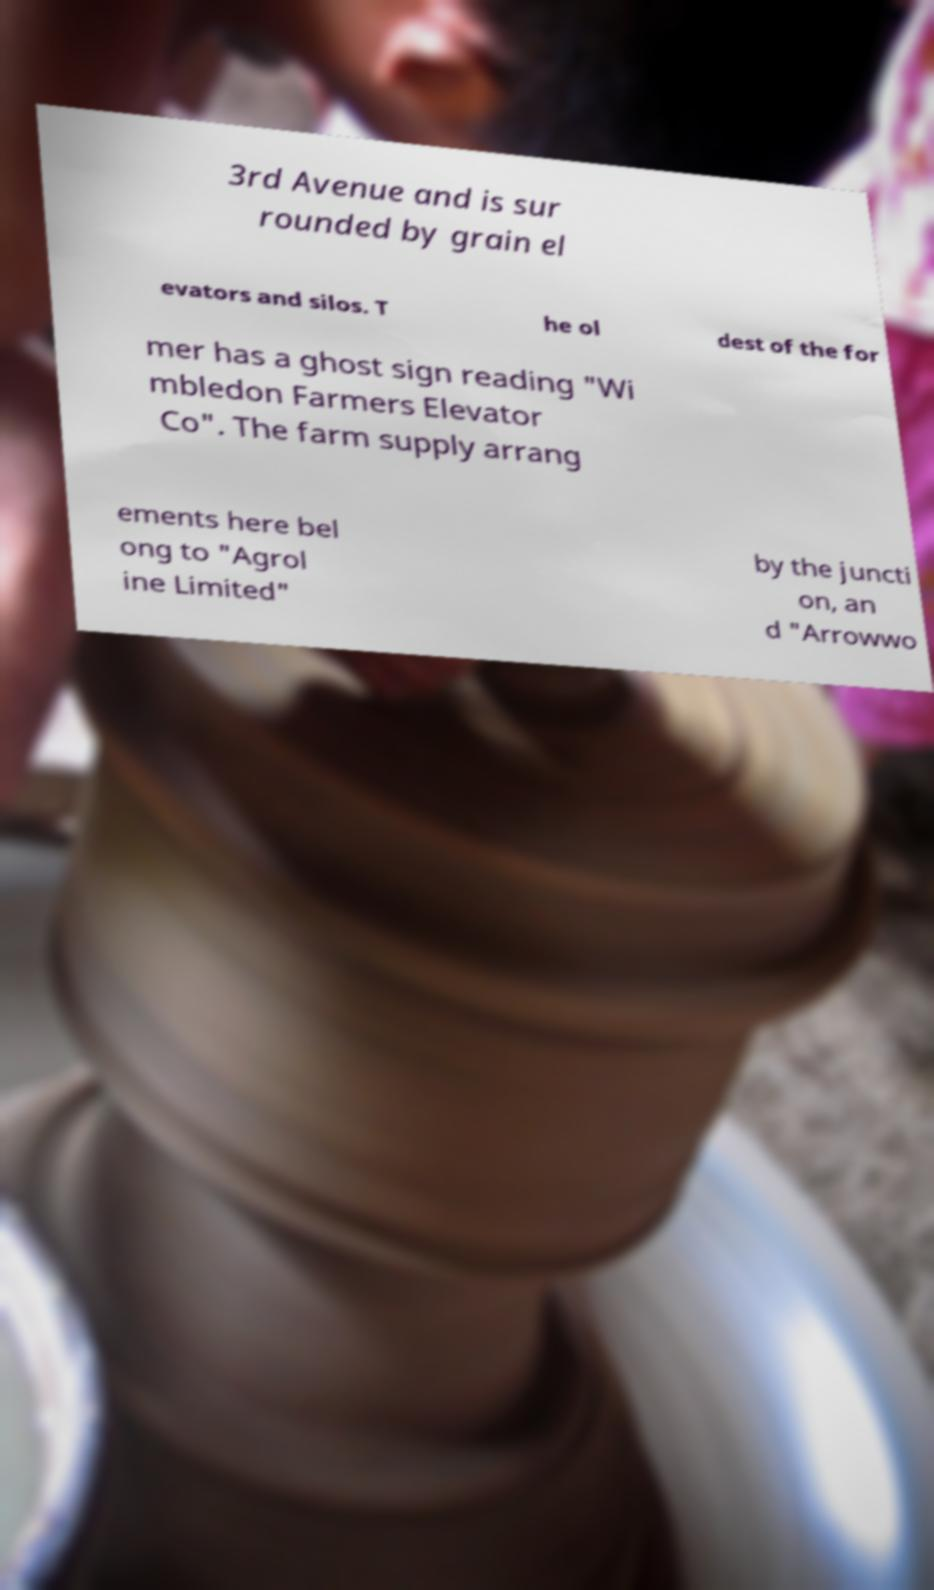Could you extract and type out the text from this image? 3rd Avenue and is sur rounded by grain el evators and silos. T he ol dest of the for mer has a ghost sign reading "Wi mbledon Farmers Elevator Co". The farm supply arrang ements here bel ong to "Agrol ine Limited" by the juncti on, an d "Arrowwo 